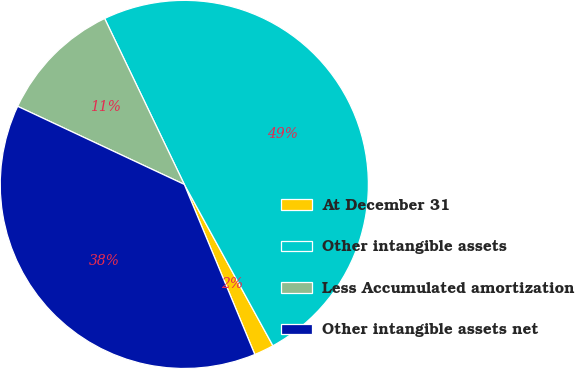<chart> <loc_0><loc_0><loc_500><loc_500><pie_chart><fcel>At December 31<fcel>Other intangible assets<fcel>Less Accumulated amortization<fcel>Other intangible assets net<nl><fcel>1.74%<fcel>49.13%<fcel>10.9%<fcel>38.23%<nl></chart> 